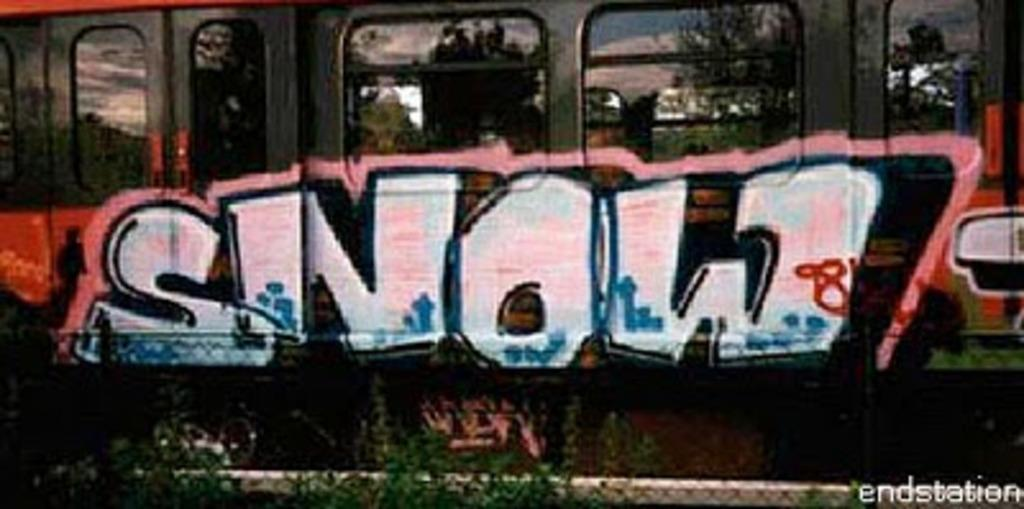<image>
Render a clear and concise summary of the photo. Someone has painted the word SNOW in a graffiti font. 